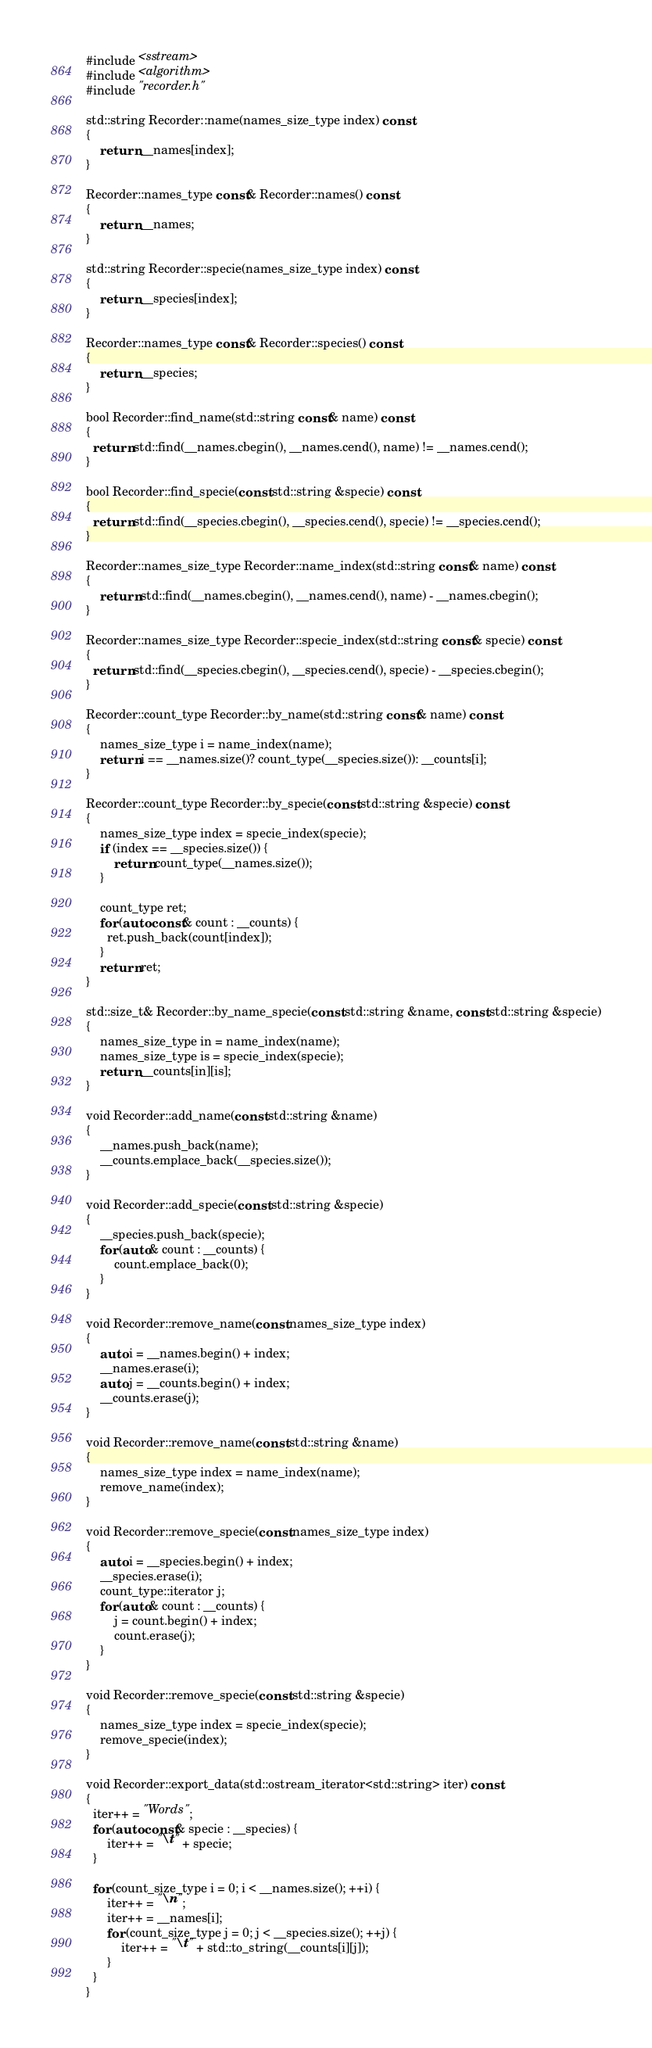<code> <loc_0><loc_0><loc_500><loc_500><_C++_>#include <sstream>
#include <algorithm>
#include "recorder.h"

std::string Recorder::name(names_size_type index) const
{
    return __names[index];
}

Recorder::names_type const& Recorder::names() const
{
    return __names;
}

std::string Recorder::specie(names_size_type index) const
{
    return __species[index];
}

Recorder::names_type const& Recorder::species() const
{
    return __species;
}

bool Recorder::find_name(std::string const& name) const
{
  return std::find(__names.cbegin(), __names.cend(), name) != __names.cend();
}

bool Recorder::find_specie(const std::string &specie) const
{
  return std::find(__species.cbegin(), __species.cend(), specie) != __species.cend();
}

Recorder::names_size_type Recorder::name_index(std::string const& name) const
{
    return std::find(__names.cbegin(), __names.cend(), name) - __names.cbegin();
}

Recorder::names_size_type Recorder::specie_index(std::string const& specie) const
{
  return std::find(__species.cbegin(), __species.cend(), specie) - __species.cbegin();
}

Recorder::count_type Recorder::by_name(std::string const& name) const
{
    names_size_type i = name_index(name);
    return i == __names.size()? count_type(__species.size()): __counts[i];
}

Recorder::count_type Recorder::by_specie(const std::string &specie) const
{
    names_size_type index = specie_index(specie);
    if (index == __species.size()) {
        return count_type(__names.size());
    }

    count_type ret;
    for (auto const& count : __counts) {
      ret.push_back(count[index]);
    }
    return ret;
}

std::size_t& Recorder::by_name_specie(const std::string &name, const std::string &specie)
{
    names_size_type in = name_index(name);
    names_size_type is = specie_index(specie);
    return __counts[in][is];
}

void Recorder::add_name(const std::string &name)
{
    __names.push_back(name);
    __counts.emplace_back(__species.size());
}

void Recorder::add_specie(const std::string &specie)
{
    __species.push_back(specie);
    for (auto& count : __counts) {
        count.emplace_back(0);
    }
}

void Recorder::remove_name(const names_size_type index)
{
    auto i = __names.begin() + index;
    __names.erase(i);
    auto j = __counts.begin() + index;
    __counts.erase(j);
}

void Recorder::remove_name(const std::string &name)
{
    names_size_type index = name_index(name);
    remove_name(index);
}

void Recorder::remove_specie(const names_size_type index)
{
    auto i = __species.begin() + index;
    __species.erase(i);
    count_type::iterator j;
    for (auto& count : __counts) {
        j = count.begin() + index;
        count.erase(j);
    }
}

void Recorder::remove_specie(const std::string &specie)
{
    names_size_type index = specie_index(specie);
    remove_specie(index);
}

void Recorder::export_data(std::ostream_iterator<std::string> iter) const
{
  iter++ = "Words";
  for (auto const& specie : __species) {
      iter++ = "\t" + specie;
  }

  for (count_size_type i = 0; i < __names.size(); ++i) {
      iter++ = "\n";
      iter++ = __names[i];
      for (count_size_type j = 0; j < __species.size(); ++j) {
          iter++ = "\t" + std::to_string(__counts[i][j]);
      }
  }
}
</code> 